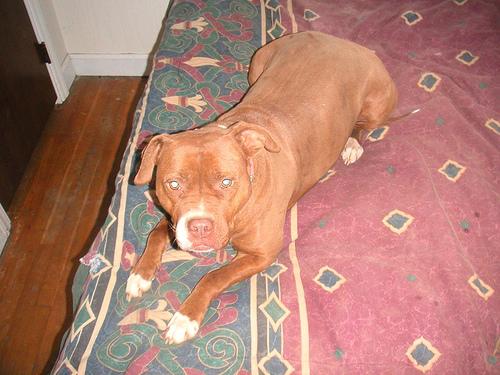Is this a dog or a pig?
Answer briefly. Dog. What are the floors made of?
Quick response, please. Wood. What is the dog laying on?
Give a very brief answer. Bed. 